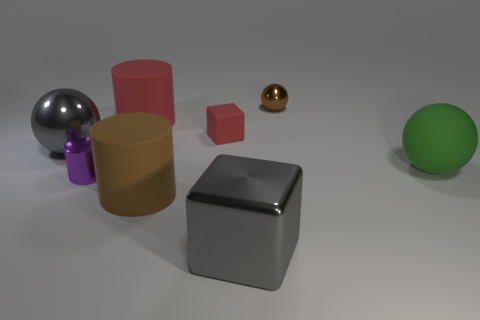There is a big brown object that is the same shape as the purple shiny object; what is its material?
Your answer should be very brief. Rubber. Are the purple object and the green ball made of the same material?
Your answer should be very brief. No. What is the color of the cube left of the gray shiny object right of the metal cylinder?
Offer a terse response. Red. What size is the brown cylinder that is the same material as the big red thing?
Offer a very short reply. Large. How many big red matte things are the same shape as the small purple metallic object?
Provide a short and direct response. 1. How many objects are rubber objects that are on the left side of the large green matte object or tiny brown objects that are to the right of the tiny red cube?
Offer a very short reply. 4. There is a big gray thing behind the brown cylinder; what number of small cylinders are behind it?
Ensure brevity in your answer.  0. There is a red object left of the small red matte cube; does it have the same shape as the big metallic thing in front of the green rubber ball?
Your answer should be very brief. No. There is a big matte thing that is the same color as the small matte object; what shape is it?
Provide a short and direct response. Cylinder. Is there a large gray thing made of the same material as the big brown cylinder?
Offer a very short reply. No. 